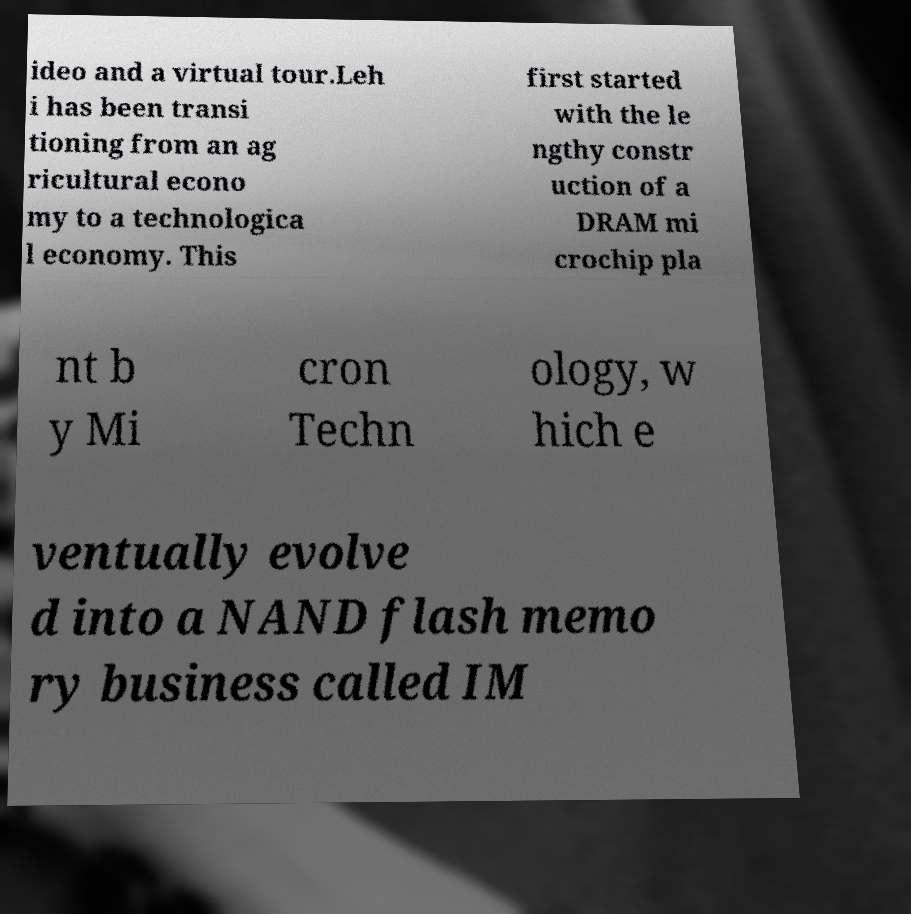Can you read and provide the text displayed in the image?This photo seems to have some interesting text. Can you extract and type it out for me? ideo and a virtual tour.Leh i has been transi tioning from an ag ricultural econo my to a technologica l economy. This first started with the le ngthy constr uction of a DRAM mi crochip pla nt b y Mi cron Techn ology, w hich e ventually evolve d into a NAND flash memo ry business called IM 